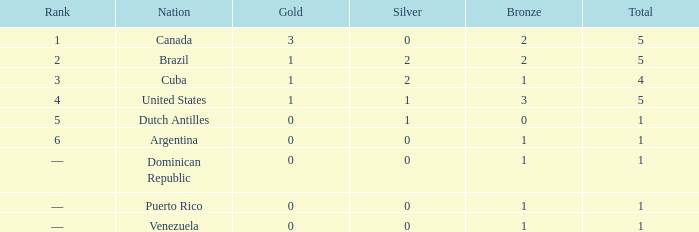What is the mean gold count for countries ranked 6th with one overall medal and one bronze medal? None. 